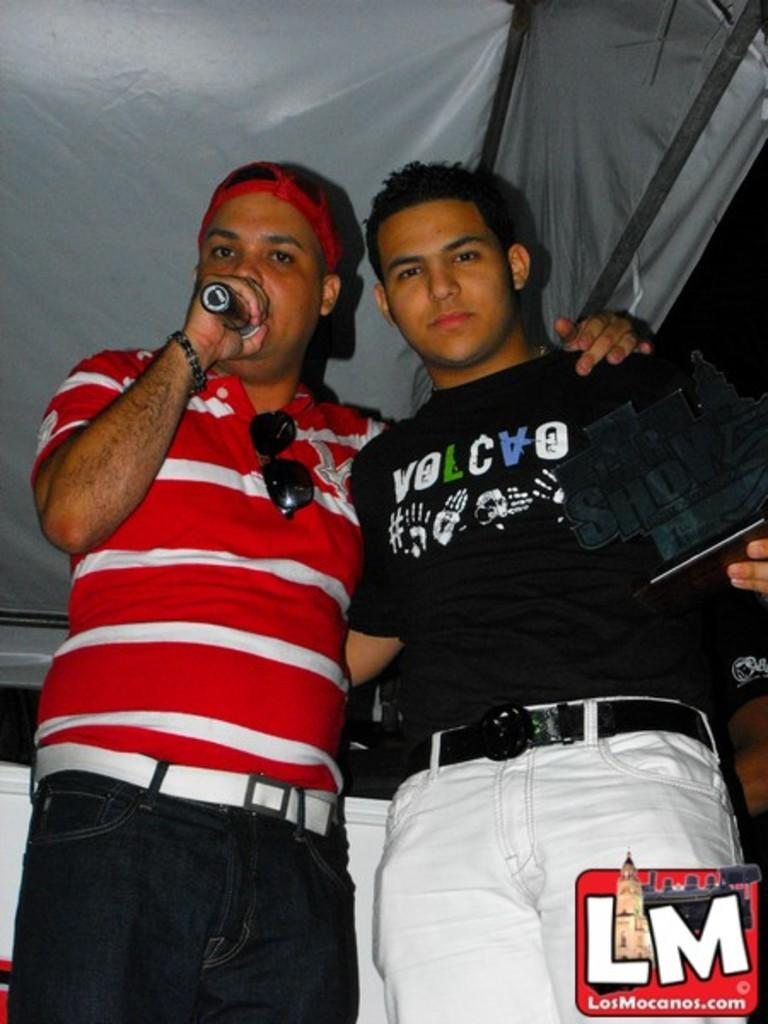<image>
Share a concise interpretation of the image provided. A man wears a black shirt with hand prints and "volcvo" on the front. 